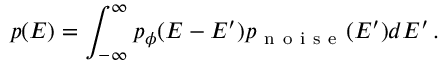<formula> <loc_0><loc_0><loc_500><loc_500>p ( E ) = \int _ { - \infty } ^ { \infty } p _ { \phi } ( E - E ^ { \prime } ) p _ { n o i s e } ( E ^ { \prime } ) d E ^ { \prime } \, .</formula> 